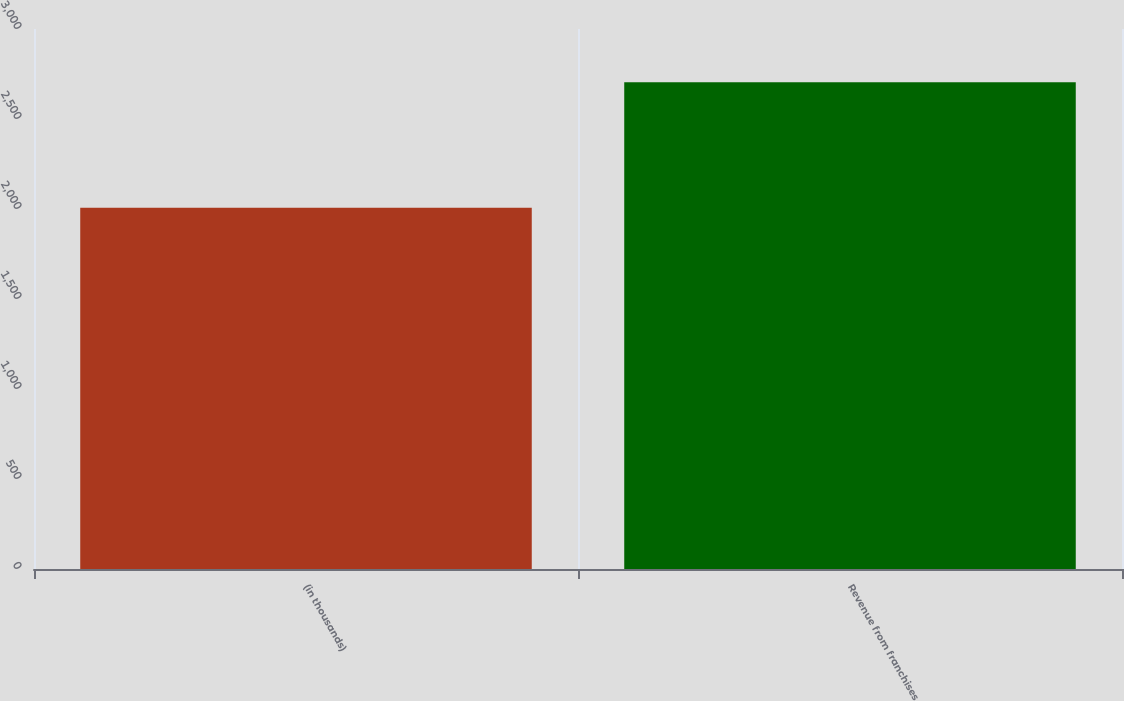<chart> <loc_0><loc_0><loc_500><loc_500><bar_chart><fcel>(in thousands)<fcel>Revenue from franchises<nl><fcel>2007<fcel>2704<nl></chart> 